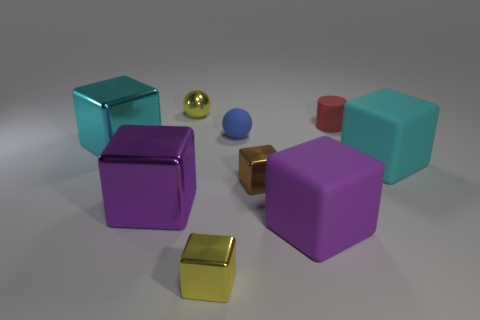Subtract 3 blocks. How many blocks are left? 3 Subtract all rubber blocks. How many blocks are left? 4 Subtract all brown blocks. How many blocks are left? 5 Subtract all green cubes. Subtract all brown cylinders. How many cubes are left? 6 Add 1 blue matte spheres. How many objects exist? 10 Subtract all balls. How many objects are left? 7 Add 4 big purple rubber blocks. How many big purple rubber blocks are left? 5 Add 2 yellow metal blocks. How many yellow metal blocks exist? 3 Subtract 1 blue balls. How many objects are left? 8 Subtract all big metal cylinders. Subtract all tiny balls. How many objects are left? 7 